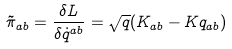<formula> <loc_0><loc_0><loc_500><loc_500>\tilde { \pi } _ { a b } = \frac { \delta L } { \delta \dot { q } ^ { a b } } = \sqrt { q } ( K _ { a b } - K q _ { a b } )</formula> 